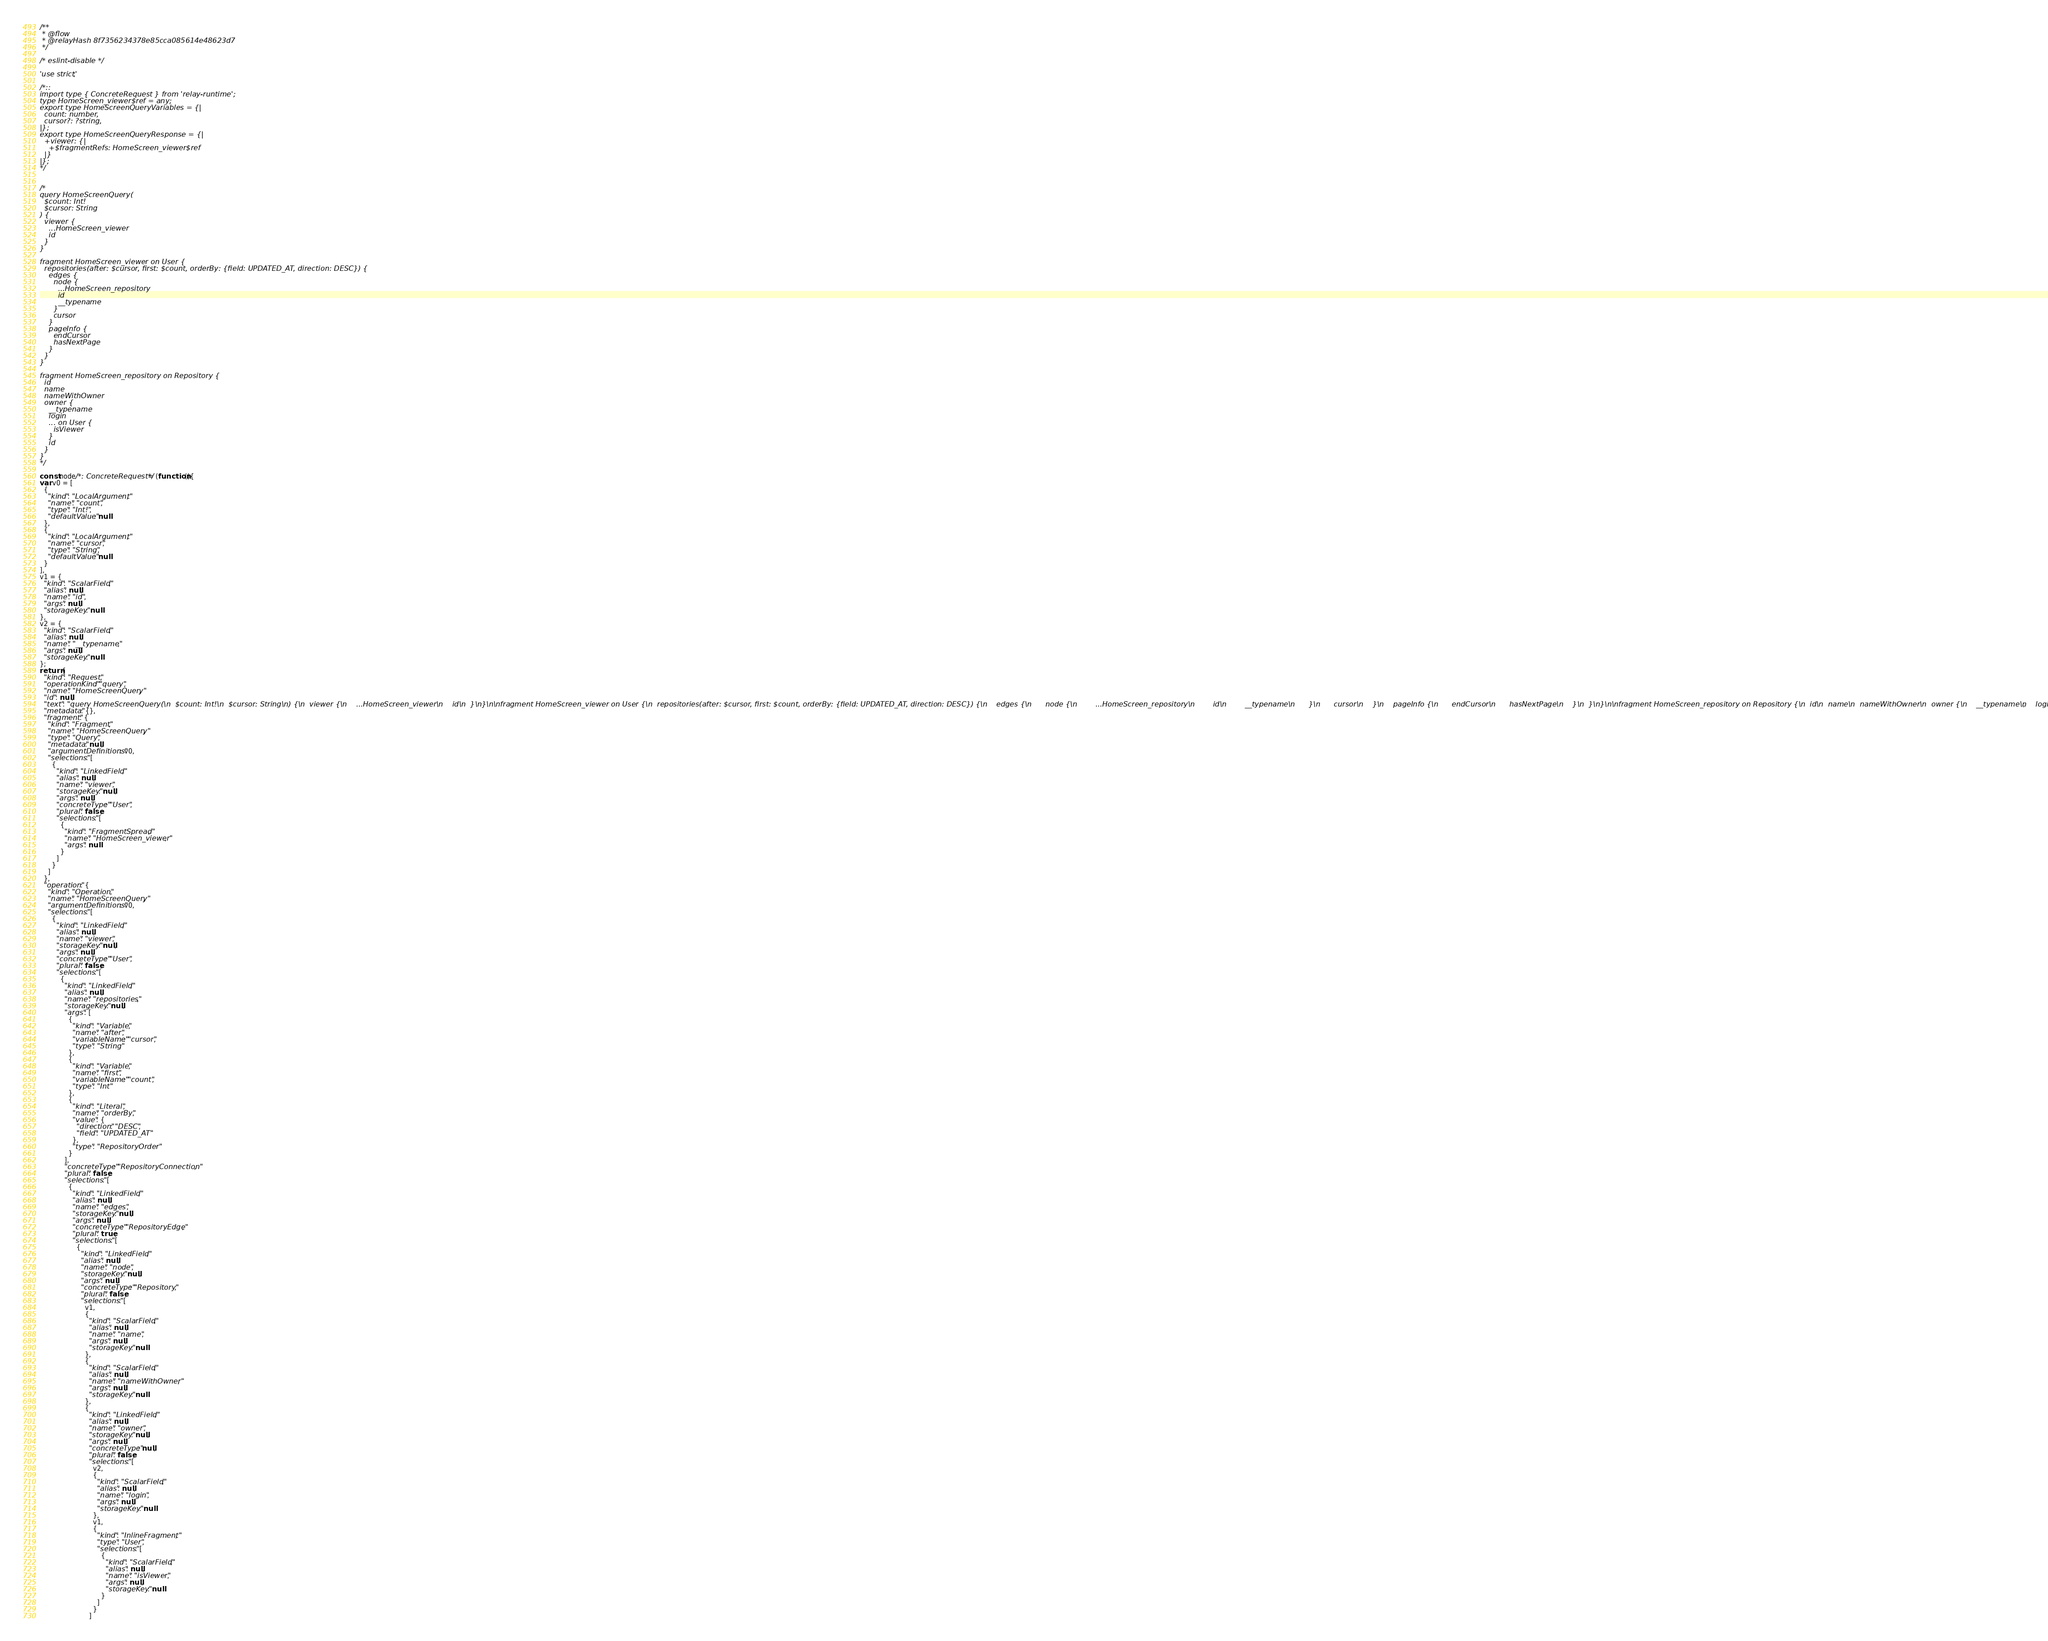Convert code to text. <code><loc_0><loc_0><loc_500><loc_500><_JavaScript_>/**
 * @flow
 * @relayHash 8f7356234378e85cca085614e48623d7
 */

/* eslint-disable */

'use strict';

/*::
import type { ConcreteRequest } from 'relay-runtime';
type HomeScreen_viewer$ref = any;
export type HomeScreenQueryVariables = {|
  count: number,
  cursor?: ?string,
|};
export type HomeScreenQueryResponse = {|
  +viewer: {|
    +$fragmentRefs: HomeScreen_viewer$ref
  |}
|};
*/


/*
query HomeScreenQuery(
  $count: Int!
  $cursor: String
) {
  viewer {
    ...HomeScreen_viewer
    id
  }
}

fragment HomeScreen_viewer on User {
  repositories(after: $cursor, first: $count, orderBy: {field: UPDATED_AT, direction: DESC}) {
    edges {
      node {
        ...HomeScreen_repository
        id
        __typename
      }
      cursor
    }
    pageInfo {
      endCursor
      hasNextPage
    }
  }
}

fragment HomeScreen_repository on Repository {
  id
  name
  nameWithOwner
  owner {
    __typename
    login
    ... on User {
      isViewer
    }
    id
  }
}
*/

const node/*: ConcreteRequest*/ = (function(){
var v0 = [
  {
    "kind": "LocalArgument",
    "name": "count",
    "type": "Int!",
    "defaultValue": null
  },
  {
    "kind": "LocalArgument",
    "name": "cursor",
    "type": "String",
    "defaultValue": null
  }
],
v1 = {
  "kind": "ScalarField",
  "alias": null,
  "name": "id",
  "args": null,
  "storageKey": null
},
v2 = {
  "kind": "ScalarField",
  "alias": null,
  "name": "__typename",
  "args": null,
  "storageKey": null
};
return {
  "kind": "Request",
  "operationKind": "query",
  "name": "HomeScreenQuery",
  "id": null,
  "text": "query HomeScreenQuery(\n  $count: Int!\n  $cursor: String\n) {\n  viewer {\n    ...HomeScreen_viewer\n    id\n  }\n}\n\nfragment HomeScreen_viewer on User {\n  repositories(after: $cursor, first: $count, orderBy: {field: UPDATED_AT, direction: DESC}) {\n    edges {\n      node {\n        ...HomeScreen_repository\n        id\n        __typename\n      }\n      cursor\n    }\n    pageInfo {\n      endCursor\n      hasNextPage\n    }\n  }\n}\n\nfragment HomeScreen_repository on Repository {\n  id\n  name\n  nameWithOwner\n  owner {\n    __typename\n    login\n    ... on User {\n      isViewer\n    }\n    id\n  }\n}\n",
  "metadata": {},
  "fragment": {
    "kind": "Fragment",
    "name": "HomeScreenQuery",
    "type": "Query",
    "metadata": null,
    "argumentDefinitions": v0,
    "selections": [
      {
        "kind": "LinkedField",
        "alias": null,
        "name": "viewer",
        "storageKey": null,
        "args": null,
        "concreteType": "User",
        "plural": false,
        "selections": [
          {
            "kind": "FragmentSpread",
            "name": "HomeScreen_viewer",
            "args": null
          }
        ]
      }
    ]
  },
  "operation": {
    "kind": "Operation",
    "name": "HomeScreenQuery",
    "argumentDefinitions": v0,
    "selections": [
      {
        "kind": "LinkedField",
        "alias": null,
        "name": "viewer",
        "storageKey": null,
        "args": null,
        "concreteType": "User",
        "plural": false,
        "selections": [
          {
            "kind": "LinkedField",
            "alias": null,
            "name": "repositories",
            "storageKey": null,
            "args": [
              {
                "kind": "Variable",
                "name": "after",
                "variableName": "cursor",
                "type": "String"
              },
              {
                "kind": "Variable",
                "name": "first",
                "variableName": "count",
                "type": "Int"
              },
              {
                "kind": "Literal",
                "name": "orderBy",
                "value": {
                  "direction": "DESC",
                  "field": "UPDATED_AT"
                },
                "type": "RepositoryOrder"
              }
            ],
            "concreteType": "RepositoryConnection",
            "plural": false,
            "selections": [
              {
                "kind": "LinkedField",
                "alias": null,
                "name": "edges",
                "storageKey": null,
                "args": null,
                "concreteType": "RepositoryEdge",
                "plural": true,
                "selections": [
                  {
                    "kind": "LinkedField",
                    "alias": null,
                    "name": "node",
                    "storageKey": null,
                    "args": null,
                    "concreteType": "Repository",
                    "plural": false,
                    "selections": [
                      v1,
                      {
                        "kind": "ScalarField",
                        "alias": null,
                        "name": "name",
                        "args": null,
                        "storageKey": null
                      },
                      {
                        "kind": "ScalarField",
                        "alias": null,
                        "name": "nameWithOwner",
                        "args": null,
                        "storageKey": null
                      },
                      {
                        "kind": "LinkedField",
                        "alias": null,
                        "name": "owner",
                        "storageKey": null,
                        "args": null,
                        "concreteType": null,
                        "plural": false,
                        "selections": [
                          v2,
                          {
                            "kind": "ScalarField",
                            "alias": null,
                            "name": "login",
                            "args": null,
                            "storageKey": null
                          },
                          v1,
                          {
                            "kind": "InlineFragment",
                            "type": "User",
                            "selections": [
                              {
                                "kind": "ScalarField",
                                "alias": null,
                                "name": "isViewer",
                                "args": null,
                                "storageKey": null
                              }
                            ]
                          }
                        ]</code> 